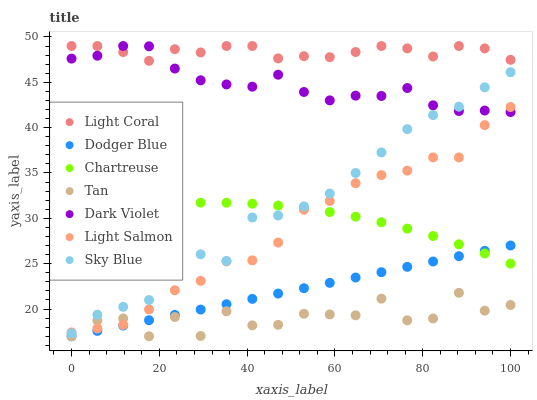Does Tan have the minimum area under the curve?
Answer yes or no. Yes. Does Light Coral have the maximum area under the curve?
Answer yes or no. Yes. Does Dark Violet have the minimum area under the curve?
Answer yes or no. No. Does Dark Violet have the maximum area under the curve?
Answer yes or no. No. Is Dodger Blue the smoothest?
Answer yes or no. Yes. Is Tan the roughest?
Answer yes or no. Yes. Is Dark Violet the smoothest?
Answer yes or no. No. Is Dark Violet the roughest?
Answer yes or no. No. Does Dodger Blue have the lowest value?
Answer yes or no. Yes. Does Dark Violet have the lowest value?
Answer yes or no. No. Does Light Coral have the highest value?
Answer yes or no. Yes. Does Chartreuse have the highest value?
Answer yes or no. No. Is Tan less than Chartreuse?
Answer yes or no. Yes. Is Light Coral greater than Light Salmon?
Answer yes or no. Yes. Does Light Salmon intersect Chartreuse?
Answer yes or no. Yes. Is Light Salmon less than Chartreuse?
Answer yes or no. No. Is Light Salmon greater than Chartreuse?
Answer yes or no. No. Does Tan intersect Chartreuse?
Answer yes or no. No. 